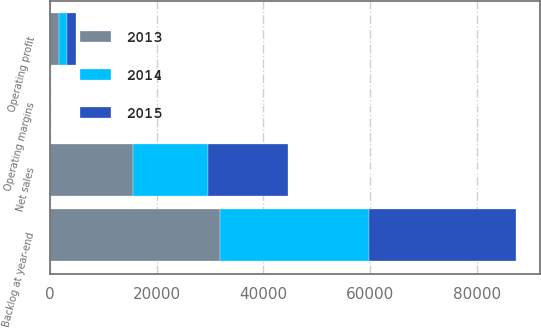<chart> <loc_0><loc_0><loc_500><loc_500><stacked_bar_chart><ecel><fcel>Net sales<fcel>Operating profit<fcel>Operating margins<fcel>Backlog at year-end<nl><fcel>2013<fcel>15570<fcel>1681<fcel>10.8<fcel>31800<nl><fcel>2015<fcel>14920<fcel>1649<fcel>11.1<fcel>27600<nl><fcel>2014<fcel>14123<fcel>1612<fcel>11.4<fcel>28000<nl></chart> 